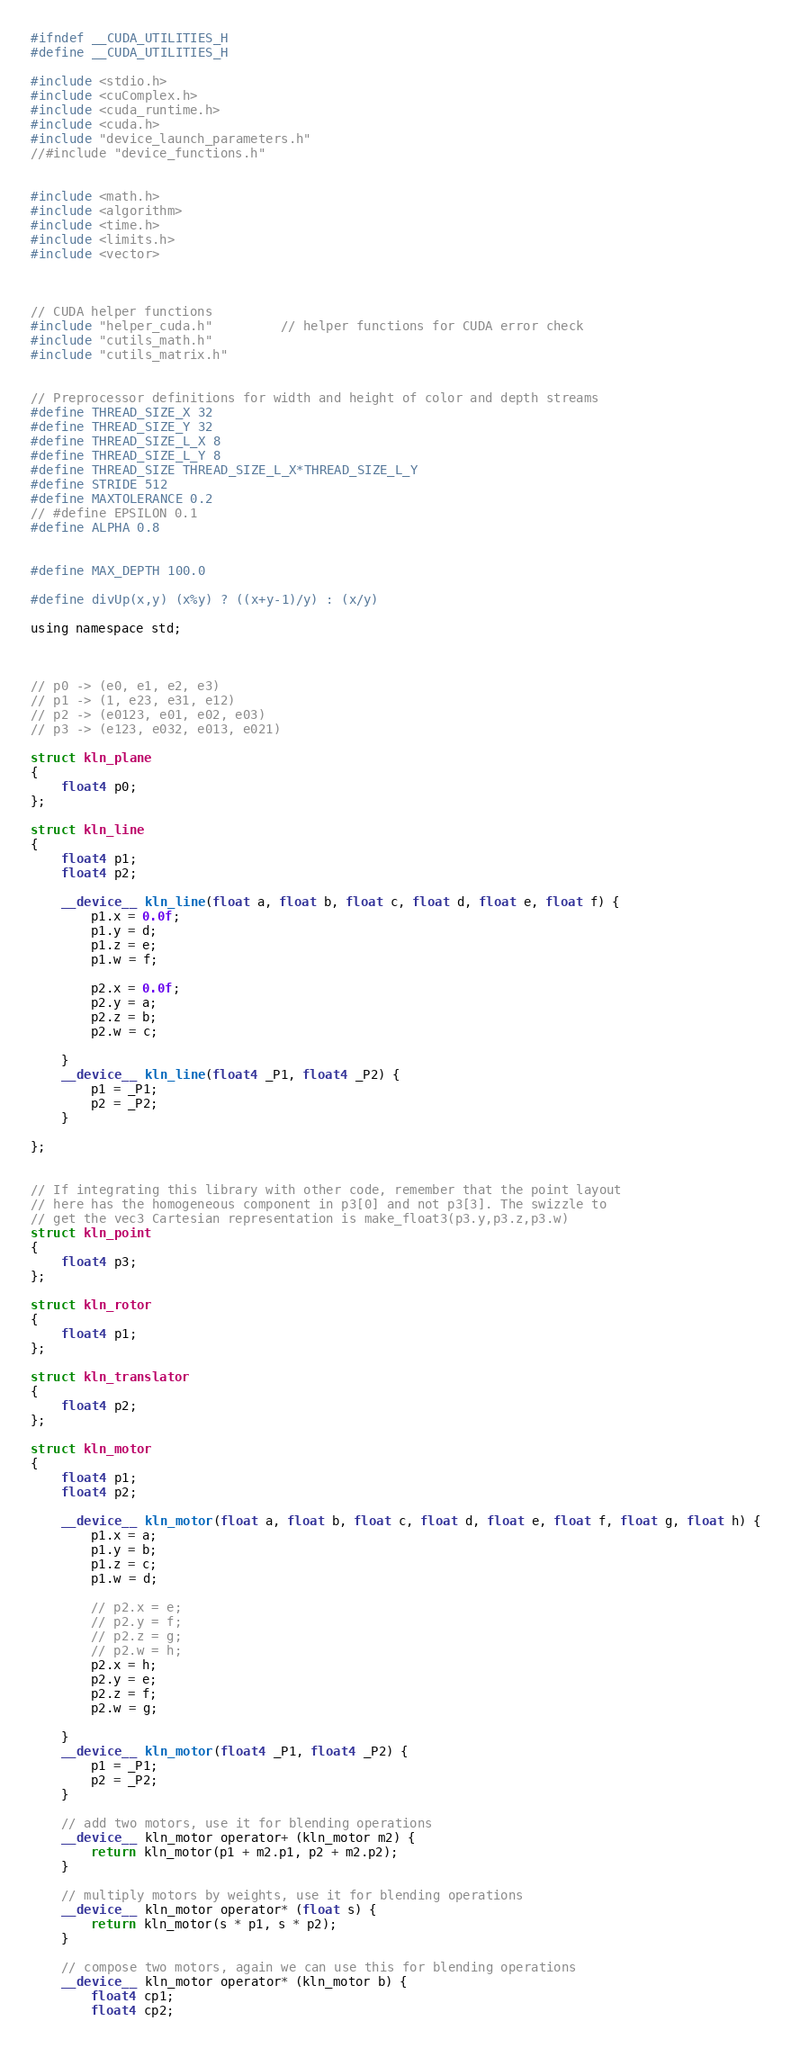Convert code to text. <code><loc_0><loc_0><loc_500><loc_500><_Cuda_>#ifndef __CUDA_UTILITIES_H
#define __CUDA_UTILITIES_H

#include <stdio.h>
#include <cuComplex.h>
#include <cuda_runtime.h>
#include <cuda.h>
#include "device_launch_parameters.h"
//#include "device_functions.h"


#include <math.h>
#include <algorithm>
#include <time.h>
#include <limits.h>
#include <vector>



// CUDA helper functions
#include "helper_cuda.h"         // helper functions for CUDA error check
#include "cutils_math.h"
#include "cutils_matrix.h"


// Preprocessor definitions for width and height of color and depth streams
#define THREAD_SIZE_X 32
#define THREAD_SIZE_Y 32
#define THREAD_SIZE_L_X 8
#define THREAD_SIZE_L_Y 8
#define THREAD_SIZE THREAD_SIZE_L_X*THREAD_SIZE_L_Y
#define STRIDE 512
#define MAXTOLERANCE 0.2
// #define EPSILON 0.1
#define ALPHA 0.8 


#define MAX_DEPTH 100.0

#define divUp(x,y) (x%y) ? ((x+y-1)/y) : (x/y)

using namespace std;



// p0 -> (e0, e1, e2, e3)
// p1 -> (1, e23, e31, e12)
// p2 -> (e0123, e01, e02, e03)
// p3 -> (e123, e032, e013, e021)

struct kln_plane
{
    float4 p0;
};

struct kln_line
{
    float4 p1;
    float4 p2;

    __device__ kln_line(float a, float b, float c, float d, float e, float f) {
        p1.x = 0.0f;
        p1.y = d;
        p1.z = e;
        p1.w = f;

        p2.x = 0.0f;
        p2.y = a;
        p2.z = b;
        p2.w = c;

    }
    __device__ kln_line(float4 _P1, float4 _P2) {
        p1 = _P1;
        p2 = _P2;
    }

};


// If integrating this library with other code, remember that the point layout
// here has the homogeneous component in p3[0] and not p3[3]. The swizzle to
// get the vec3 Cartesian representation is make_float3(p3.y,p3.z,p3.w)
struct kln_point
{
    float4 p3;
};

struct kln_rotor
{
    float4 p1;
};

struct kln_translator
{
    float4 p2;
};

struct kln_motor
{
    float4 p1;
    float4 p2;

    __device__ kln_motor(float a, float b, float c, float d, float e, float f, float g, float h) {
        p1.x = a;
        p1.y = b;
        p1.z = c;
        p1.w = d;

        // p2.x = e;
        // p2.y = f;
        // p2.z = g;
        // p2.w = h;
        p2.x = h;
        p2.y = e;
        p2.z = f;
        p2.w = g;

    }
    __device__ kln_motor(float4 _P1, float4 _P2) {
        p1 = _P1;
        p2 = _P2;
    }

    // add two motors, use it for blending operations
    __device__ kln_motor operator+ (kln_motor m2) {
        return kln_motor(p1 + m2.p1, p2 + m2.p2);
    }

    // multiply motors by weights, use it for blending operations
    __device__ kln_motor operator* (float s) {
        return kln_motor(s * p1, s * p2);
    }

    // compose two motors, again we can use this for blending operations
    __device__ kln_motor operator* (kln_motor b) {
        float4 cp1;
        float4 cp2;
</code> 